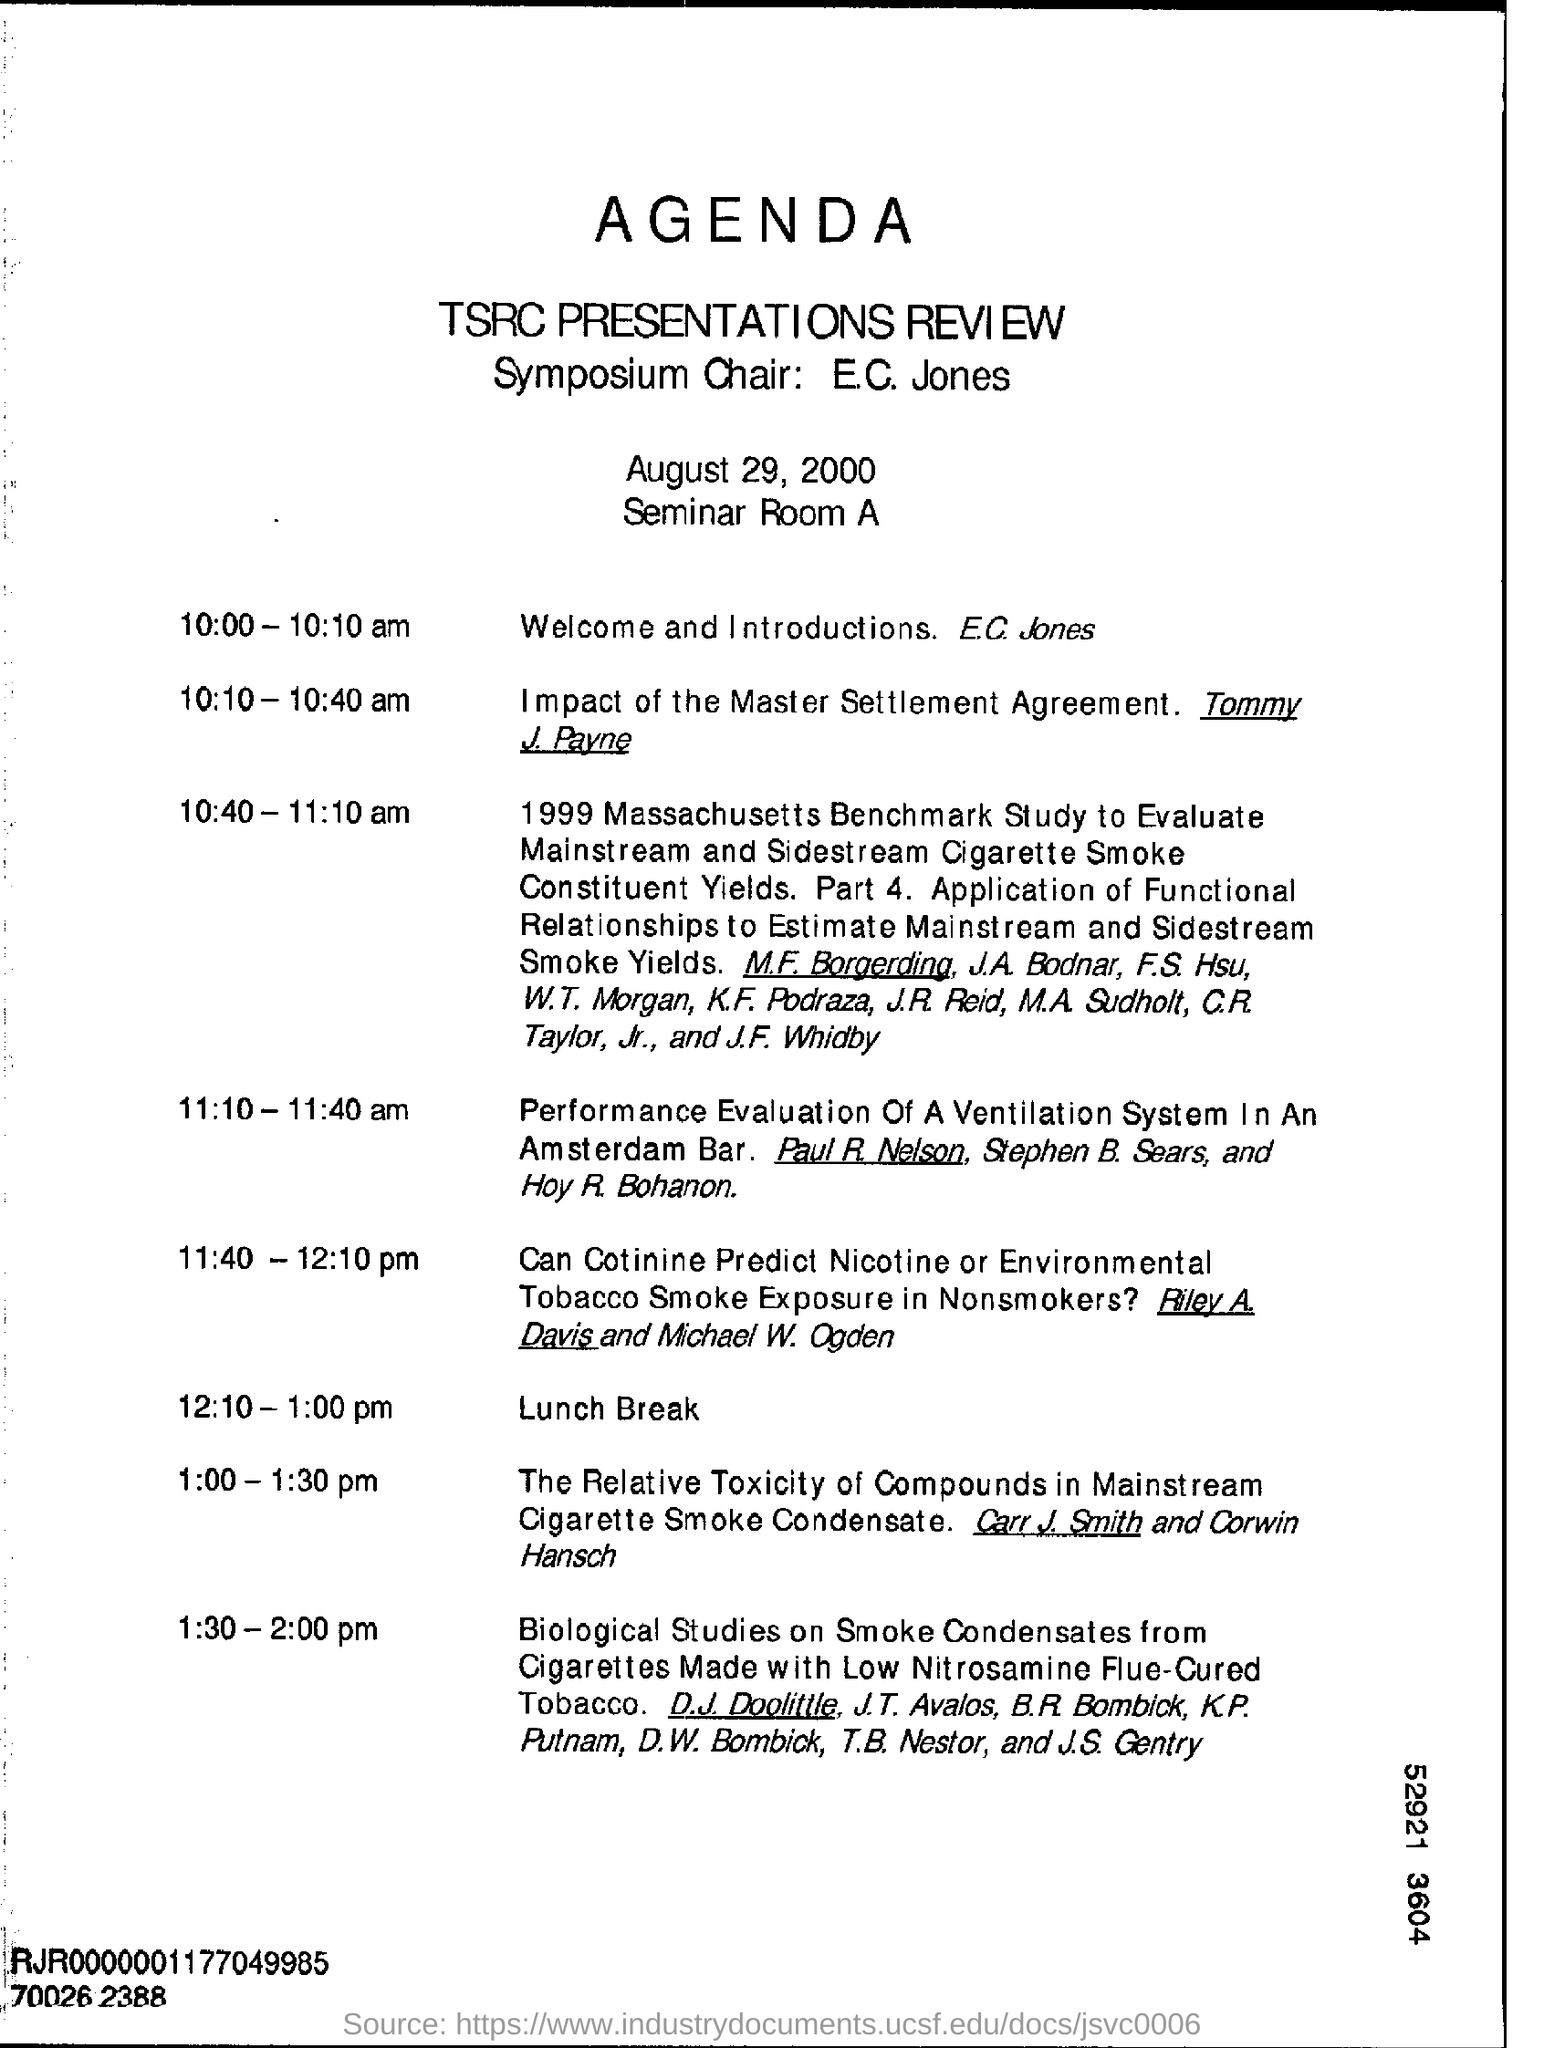At what time is the welcome and introductions by E.C. Jones?
Offer a terse response. 10:00 - 10:10 am. When is the seminar conducted?
Offer a terse response. August 29, 2000. At what time does the lunch break start?
Offer a very short reply. 12:10. Who'll give the welcome and introduction speech ?
Provide a short and direct response. E.C. Jones. 